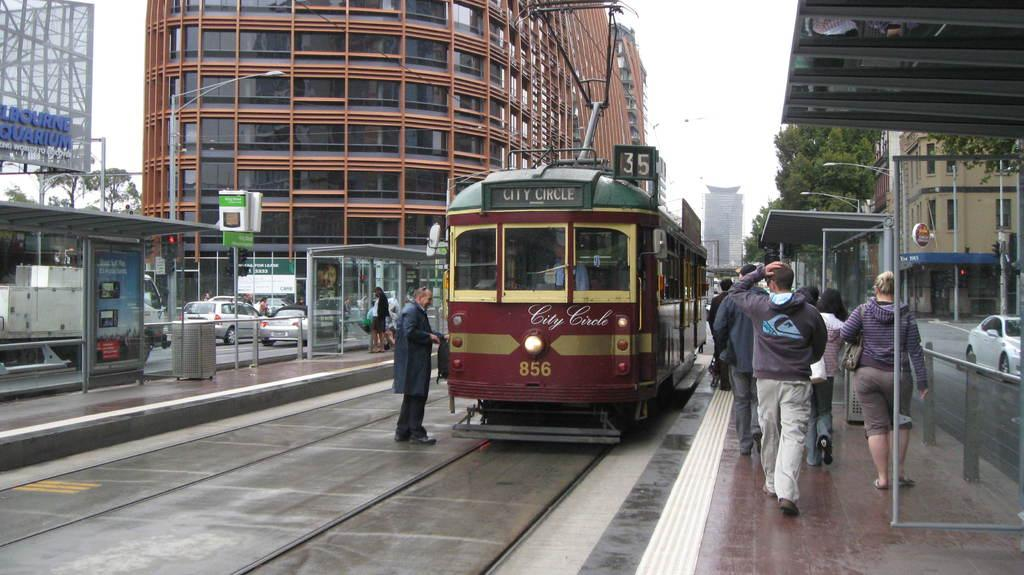What type of vehicle is present in the image? There is a bus in the image. What other types of vehicles can be seen in the image? Cars are present on the roads in the image. What are the people in the image doing? People are walking on platforms in the image. What structures are present for shelter in the image? There are shelters in the image. What additional signage is present in the image? There are banners in the image. What type of vegetation is visible in the image? Trees are present in the image. What type of buildings can be seen in the image? Buildings with windows are visible in the image. What is visible in the background of the image? The sky is visible in the background of the image. What word is written on the chalkboard in the image? There is no chalkboard present in the image, so it is not possible to answer that question. 